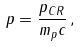<formula> <loc_0><loc_0><loc_500><loc_500>p = \frac { p _ { C R } } { m _ { p } c } \, ,</formula> 